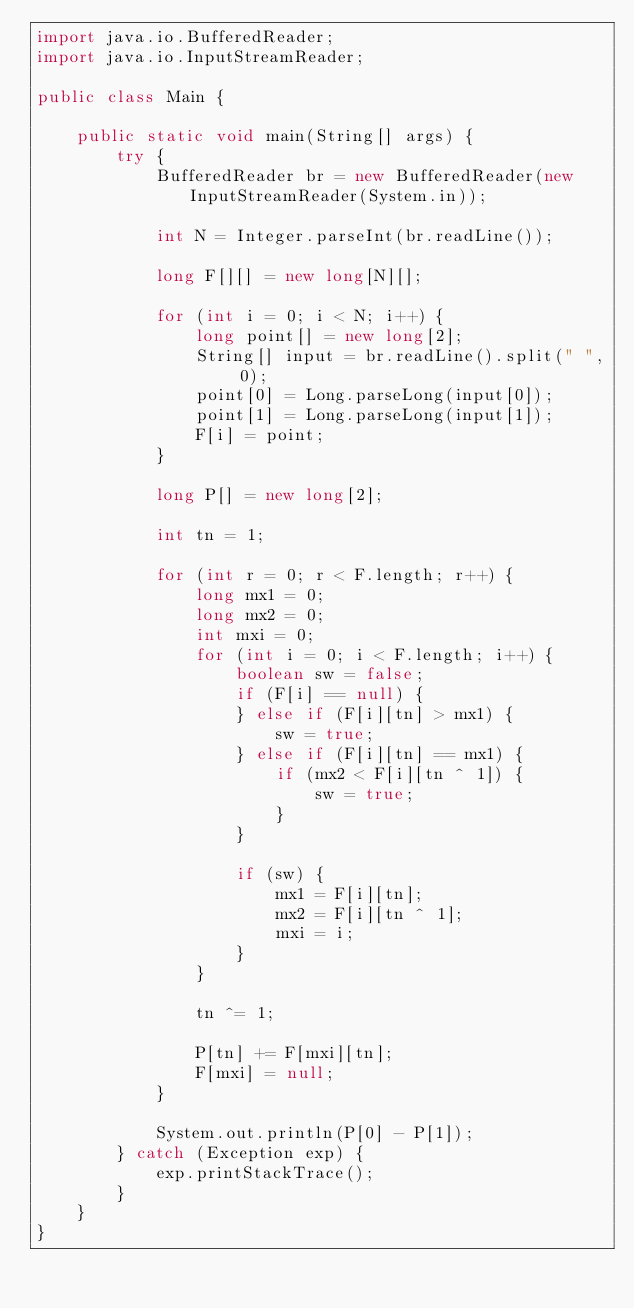Convert code to text. <code><loc_0><loc_0><loc_500><loc_500><_Java_>import java.io.BufferedReader;
import java.io.InputStreamReader;

public class Main {

	public static void main(String[] args) {
		try {
			BufferedReader br = new BufferedReader(new InputStreamReader(System.in));

			int N = Integer.parseInt(br.readLine());

			long F[][] = new long[N][];

			for (int i = 0; i < N; i++) {
				long point[] = new long[2];
				String[] input = br.readLine().split(" ", 0);
				point[0] = Long.parseLong(input[0]);
				point[1] = Long.parseLong(input[1]);
				F[i] = point;
			}

			long P[] = new long[2];

			int tn = 1;

			for (int r = 0; r < F.length; r++) {
				long mx1 = 0;
				long mx2 = 0;
				int mxi = 0;
				for (int i = 0; i < F.length; i++) {
					boolean sw = false;
					if (F[i] == null) {
					} else if (F[i][tn] > mx1) {
						sw = true;
					} else if (F[i][tn] == mx1) {
						if (mx2 < F[i][tn ^ 1]) {
							sw = true;
						}
					}

					if (sw) {
						mx1 = F[i][tn];
						mx2 = F[i][tn ^ 1];
						mxi = i;
					}
				}

				tn ^= 1;

				P[tn] += F[mxi][tn];
				F[mxi] = null;
			}

			System.out.println(P[0] - P[1]);
		} catch (Exception exp) {
			exp.printStackTrace();
		}
	}
}
</code> 